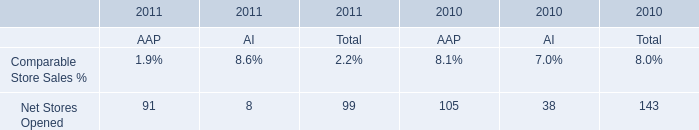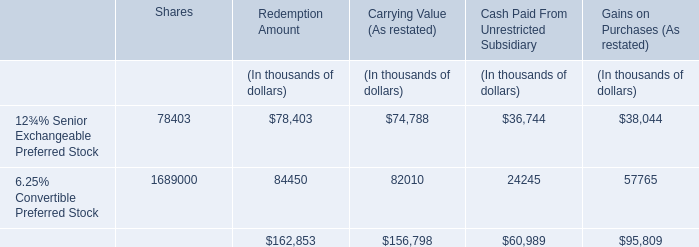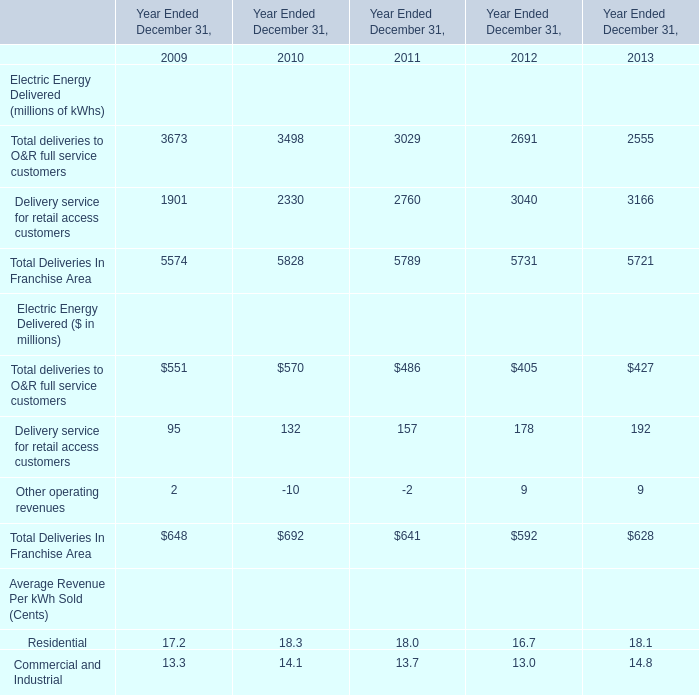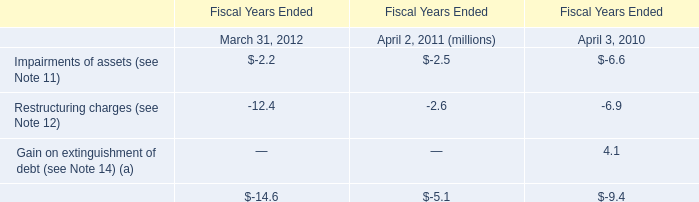What is the ratio of Total deliveries to O&R full service customers for lectric Energy Delivered ($ in millions) to the Impairments of assets (see Note 11) in 2012? 
Computations: (405 / -2.2)
Answer: -184.09091. 